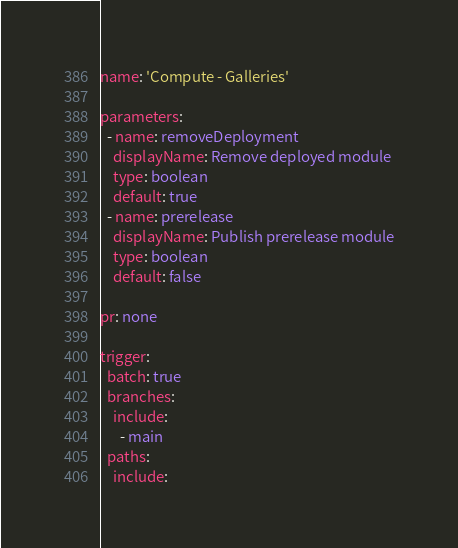<code> <loc_0><loc_0><loc_500><loc_500><_YAML_>name: 'Compute - Galleries'

parameters:
  - name: removeDeployment
    displayName: Remove deployed module
    type: boolean
    default: true
  - name: prerelease
    displayName: Publish prerelease module
    type: boolean
    default: false

pr: none

trigger:
  batch: true
  branches:
    include:
      - main
  paths:
    include:</code> 